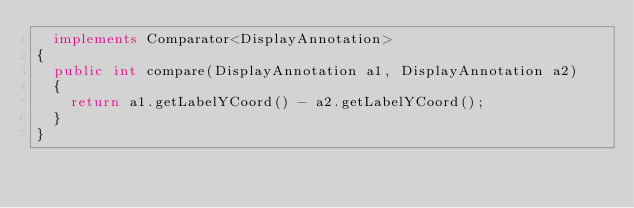<code> <loc_0><loc_0><loc_500><loc_500><_Java_>  implements Comparator<DisplayAnnotation>
{
  public int compare(DisplayAnnotation a1, DisplayAnnotation a2)
  {
    return a1.getLabelYCoord() - a2.getLabelYCoord();
  }
}</code> 